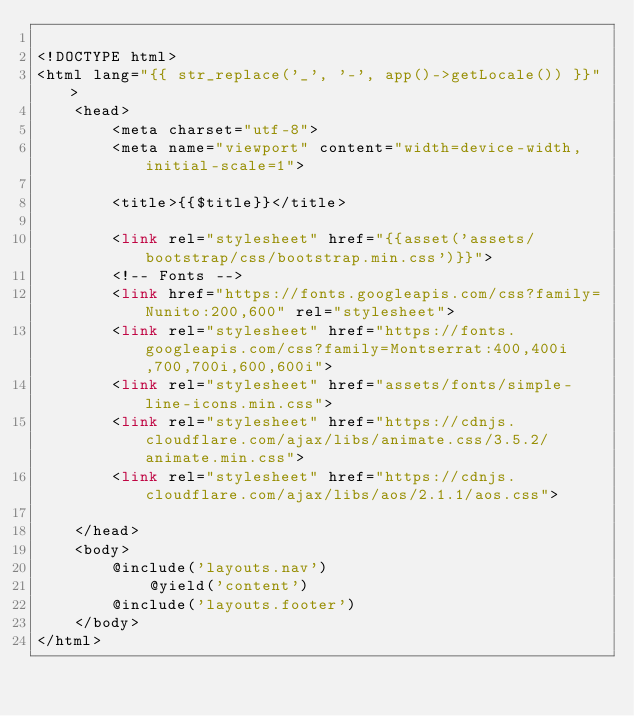Convert code to text. <code><loc_0><loc_0><loc_500><loc_500><_PHP_>
<!DOCTYPE html>
<html lang="{{ str_replace('_', '-', app()->getLocale()) }}">
    <head>
        <meta charset="utf-8">
        <meta name="viewport" content="width=device-width, initial-scale=1">

        <title>{{$title}}</title>

        <link rel="stylesheet" href="{{asset('assets/bootstrap/css/bootstrap.min.css')}}">
        <!-- Fonts -->
        <link href="https://fonts.googleapis.com/css?family=Nunito:200,600" rel="stylesheet">
        <link rel="stylesheet" href="https://fonts.googleapis.com/css?family=Montserrat:400,400i,700,700i,600,600i">
        <link rel="stylesheet" href="assets/fonts/simple-line-icons.min.css">
        <link rel="stylesheet" href="https://cdnjs.cloudflare.com/ajax/libs/animate.css/3.5.2/animate.min.css">
        <link rel="stylesheet" href="https://cdnjs.cloudflare.com/ajax/libs/aos/2.1.1/aos.css">
        
    </head>
    <body>
        @include('layouts.nav')
            @yield('content')
        @include('layouts.footer')
    </body>
</html>
</code> 